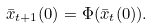<formula> <loc_0><loc_0><loc_500><loc_500>\bar { x } _ { t + 1 } ( 0 ) = \Phi ( \bar { x } _ { t } ( 0 ) ) .</formula> 